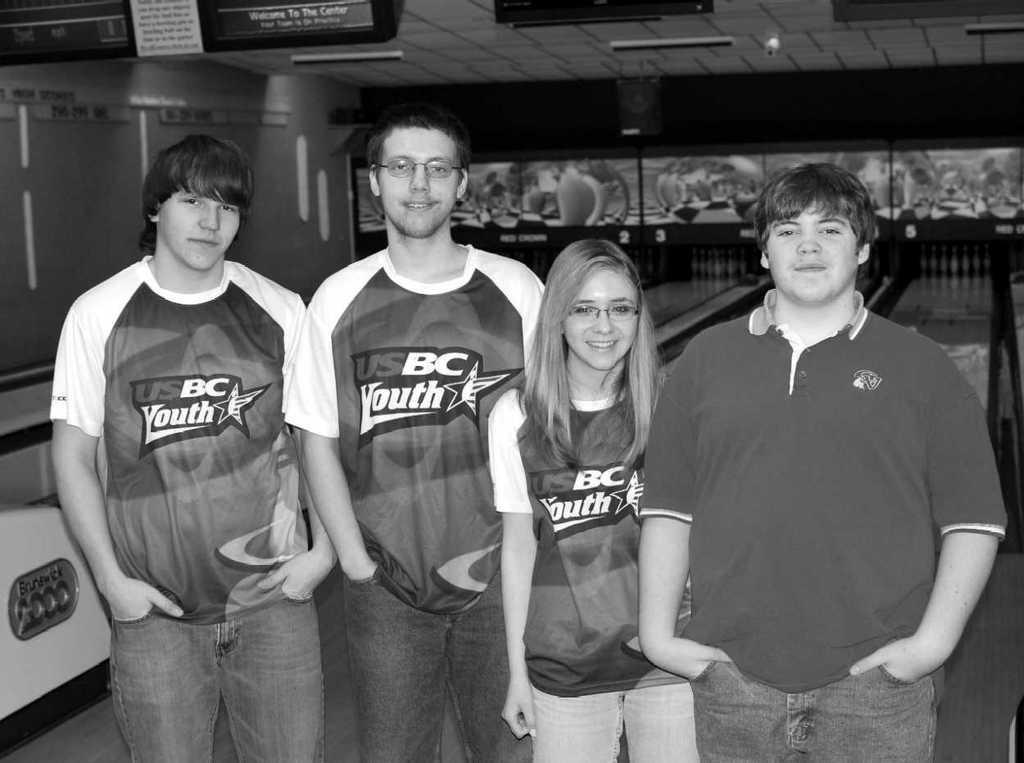In one or two sentences, can you explain what this image depicts? In this in the foreground there are few peoples, at the top there is the roof, on which there are some lights, in the middle there play board visible. 